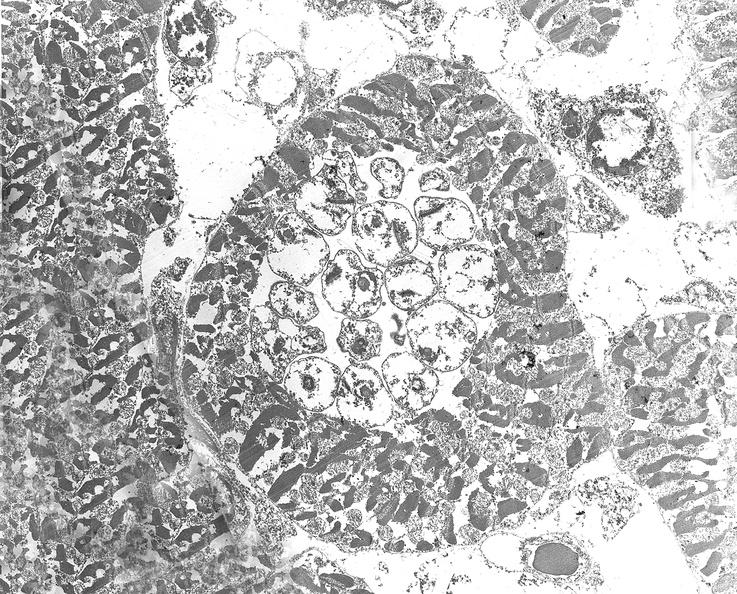where is this?
Answer the question using a single word or phrase. Heart 